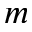Convert formula to latex. <formula><loc_0><loc_0><loc_500><loc_500>m</formula> 